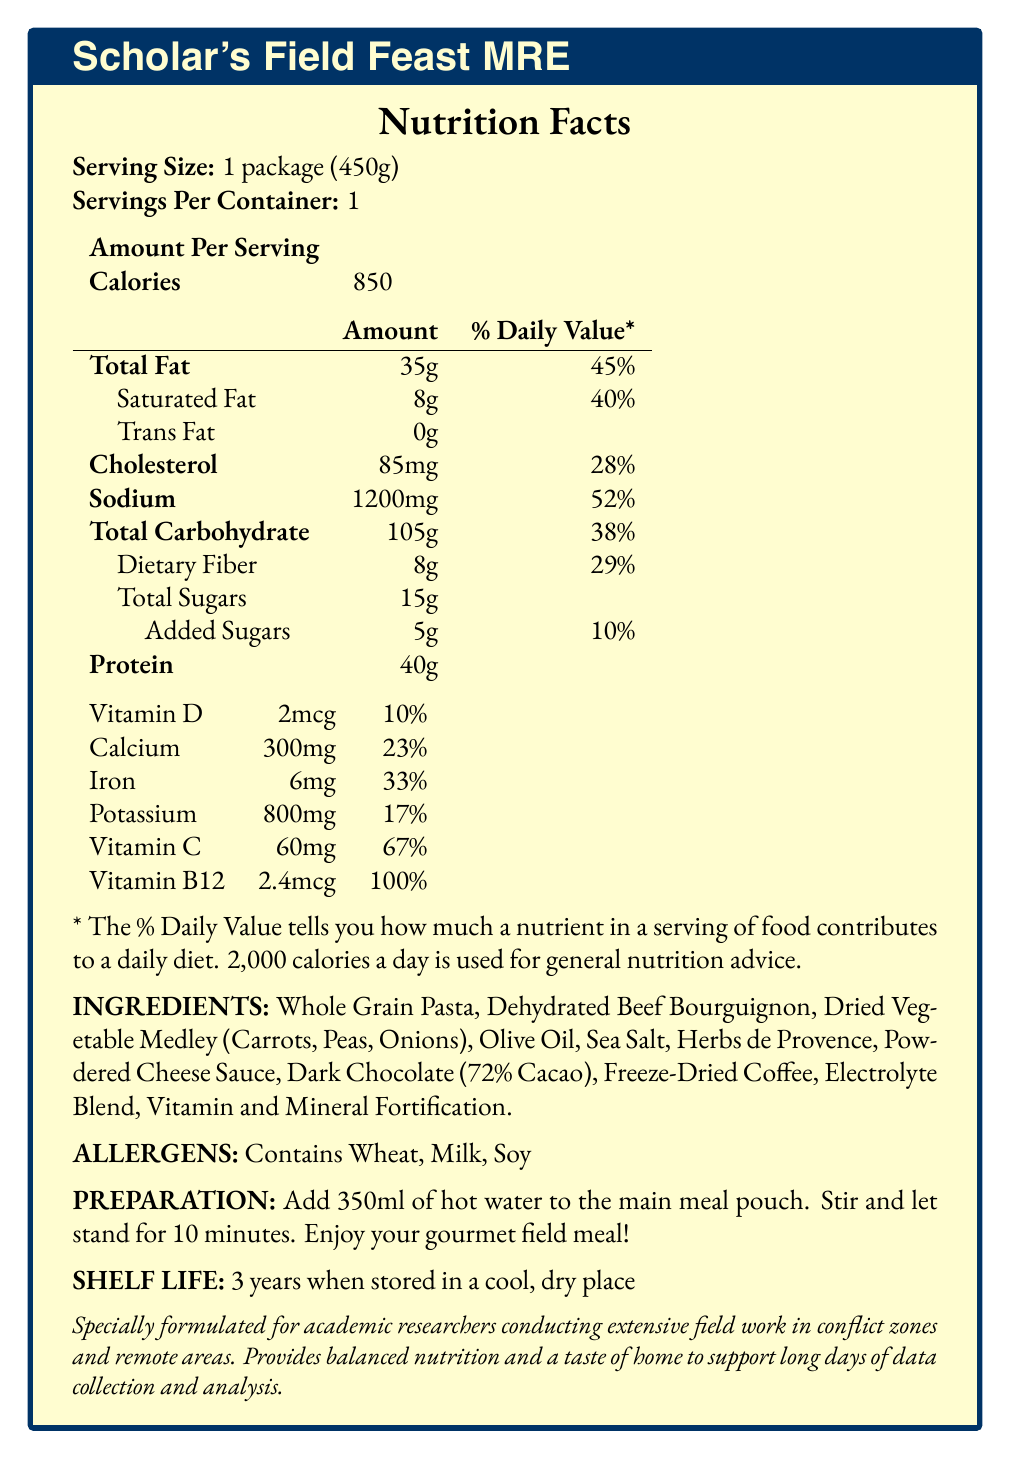what is the serving size of Scholar's Field Feast MRE? The serving size is explicitly mentioned in the Nutrition Facts section as "1 package (450g)".
Answer: 1 package (450g) how many calories are in one serving of Scholar's Field Feast MRE? The calorie content per serving is listed as 850 calories in the Amount Per Serving section.
Answer: 850 what percentage of the daily value of dietary fiber does one serving provide? The daily value percentage for dietary fiber is directly mentioned as 29% in the nutrient breakdown.
Answer: 29% list three main ingredients included in Scholar's Field Feast MRE. These ingredients are listed under the INGREDIENTS section of the document.
Answer: Whole Grain Pasta, Dehydrated Beef Bourguignon, Dried Vegetable Medley (Carrots, Peas, Onions) what is the preparation method for the MRE? The preparation instructions are clearly detailed in the document under the PREPARATION section.
Answer: Add 350ml of hot water to the main meal pouch. Stir and let stand for 10 minutes. Enjoy your gourmet field meal! which of the following nutrients has the highest daily value percentage? A. Vitamin C B. Iron C. Vitamin D D. Calcium Vitamin C has a daily value percentage of 67%, which is higher than Iron (33%), Vitamin D (10%), and Calcium (23%).
Answer: A. Vitamin C how much saturated fat is there in one serving of the MRE? A. 3g B. 8g C. 12g D. 5g The amount of saturated fat per serving is specified as 8g.
Answer: B. 8g is the Scholar's Field Feast MRE gluten-free? The MRE contains wheat, which is listed under the ALLERGENS section, indicating that it is not gluten-free.
Answer: No does the MRE contain any added sugars? The document lists "Added Sugars" at 5g, confirming the presence of added sugars.
Answer: Yes summarize the main purpose of Scholar's Field Feast MRE based on the document. The document provides comprehensive nutritional details, ingredients, allergens, and preparation instructions intended for researchers in demanding environments, emphasizing balanced nutrition and the convenience of preparation.
Answer: The Scholar's Field Feast MRE is designed to provide balanced nutrition and a taste of home for academic researchers conducting extensive fieldwork in conflict zones and remote areas. It includes detailed nutritional information, a preparation method, long shelf life, and ingredient details to support long days of data collection and analysis. what is the source of protein in the MRE? The document provides nutritional values but does not specify the exact source of protein.
Answer: Cannot be determined 